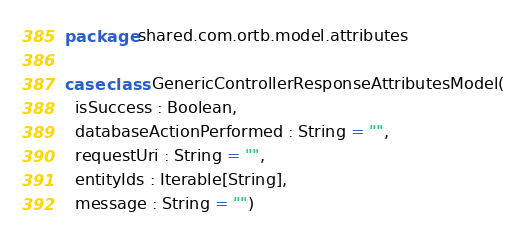<code> <loc_0><loc_0><loc_500><loc_500><_Scala_>package shared.com.ortb.model.attributes

case class GenericControllerResponseAttributesModel(
  isSuccess : Boolean,
  databaseActionPerformed : String = "",
  requestUri : String = "",
  entityIds : Iterable[String],
  message : String = "")
</code> 